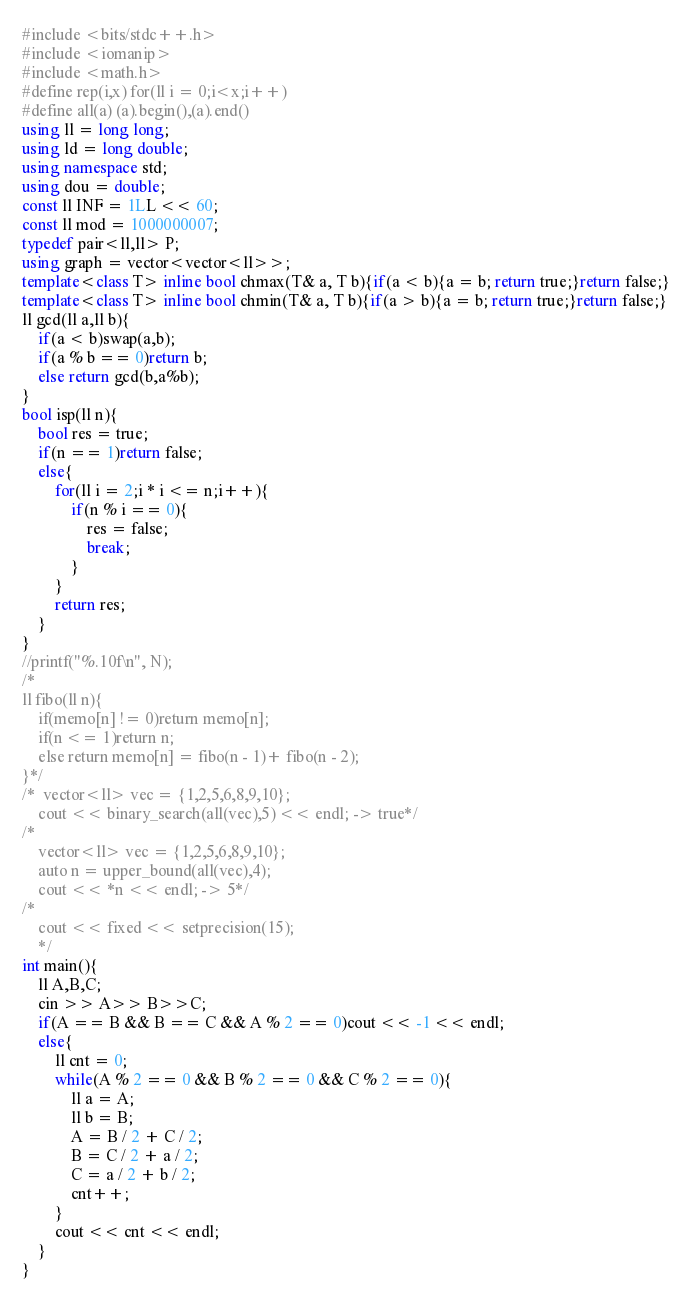<code> <loc_0><loc_0><loc_500><loc_500><_C++_>#include <bits/stdc++.h>
#include <iomanip>
#include <math.h>
#define rep(i,x) for(ll i = 0;i<x;i++)
#define all(a) (a).begin(),(a).end()
using ll = long long;
using ld = long double;
using namespace std;
using dou = double;
const ll INF = 1LL << 60;
const ll mod = 1000000007;
typedef pair<ll,ll> P;
using graph = vector<vector<ll>>;
template<class T> inline bool chmax(T& a, T b){if(a < b){a = b; return true;}return false;}
template<class T> inline bool chmin(T& a, T b){if(a > b){a = b; return true;}return false;}
ll gcd(ll a,ll b){
    if(a < b)swap(a,b);
    if(a % b == 0)return b;
    else return gcd(b,a%b);
}
bool isp(ll n){
    bool res = true;
    if(n == 1)return false;
    else{
        for(ll i = 2;i * i <= n;i++){
            if(n % i == 0){
                res = false;
                break;
            }
        }
        return res;
    }
}
//printf("%.10f\n", N);
/*
ll fibo(ll n){
    if(memo[n] != 0)return memo[n];
    if(n <= 1)return n;
    else return memo[n] = fibo(n - 1)+ fibo(n - 2);
}*/
/*  vector<ll> vec = {1,2,5,6,8,9,10};
    cout << binary_search(all(vec),5) << endl; -> true*/
/*
    vector<ll> vec = {1,2,5,6,8,9,10};
    auto n = upper_bound(all(vec),4);
    cout << *n << endl; -> 5*/
/*
    cout << fixed << setprecision(15);
    */
int main(){
    ll A,B,C;
    cin >> A>> B>>C;
    if(A == B && B == C && A % 2 == 0)cout << -1 << endl;
    else{
        ll cnt = 0;
        while(A % 2 == 0 && B % 2 == 0 && C % 2 == 0){
            ll a = A;
            ll b = B;
            A = B / 2 + C / 2;
            B = C / 2 + a / 2;
            C = a / 2 + b / 2;
            cnt++;
        }
        cout << cnt << endl;
    }
}</code> 